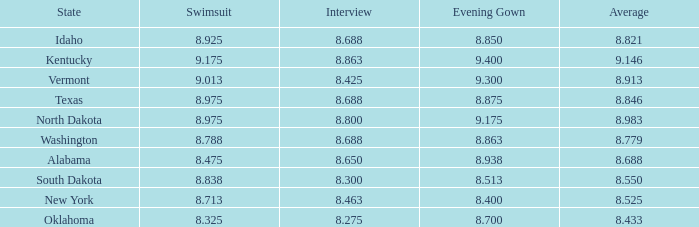What is the lowest evening score of the contestant with an evening gown less than 8.938, from Texas, and with an average less than 8.846 has? None. 